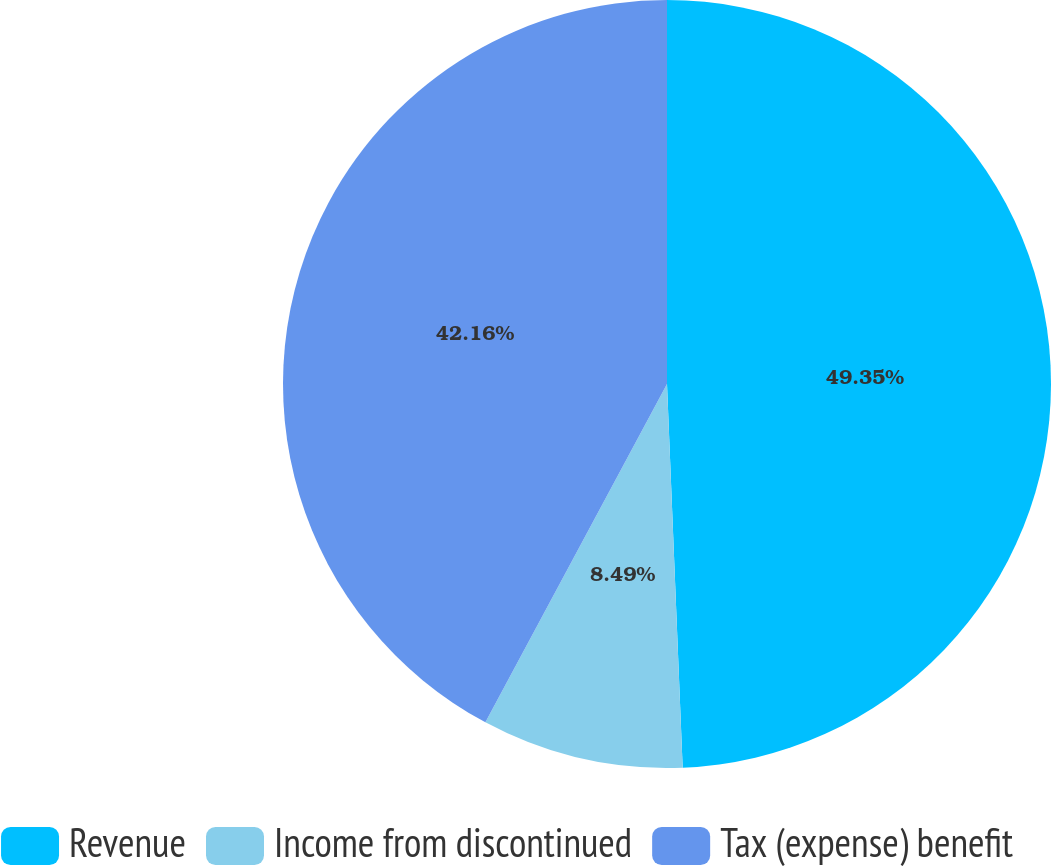Convert chart to OTSL. <chart><loc_0><loc_0><loc_500><loc_500><pie_chart><fcel>Revenue<fcel>Income from discontinued<fcel>Tax (expense) benefit<nl><fcel>49.35%<fcel>8.49%<fcel>42.16%<nl></chart> 